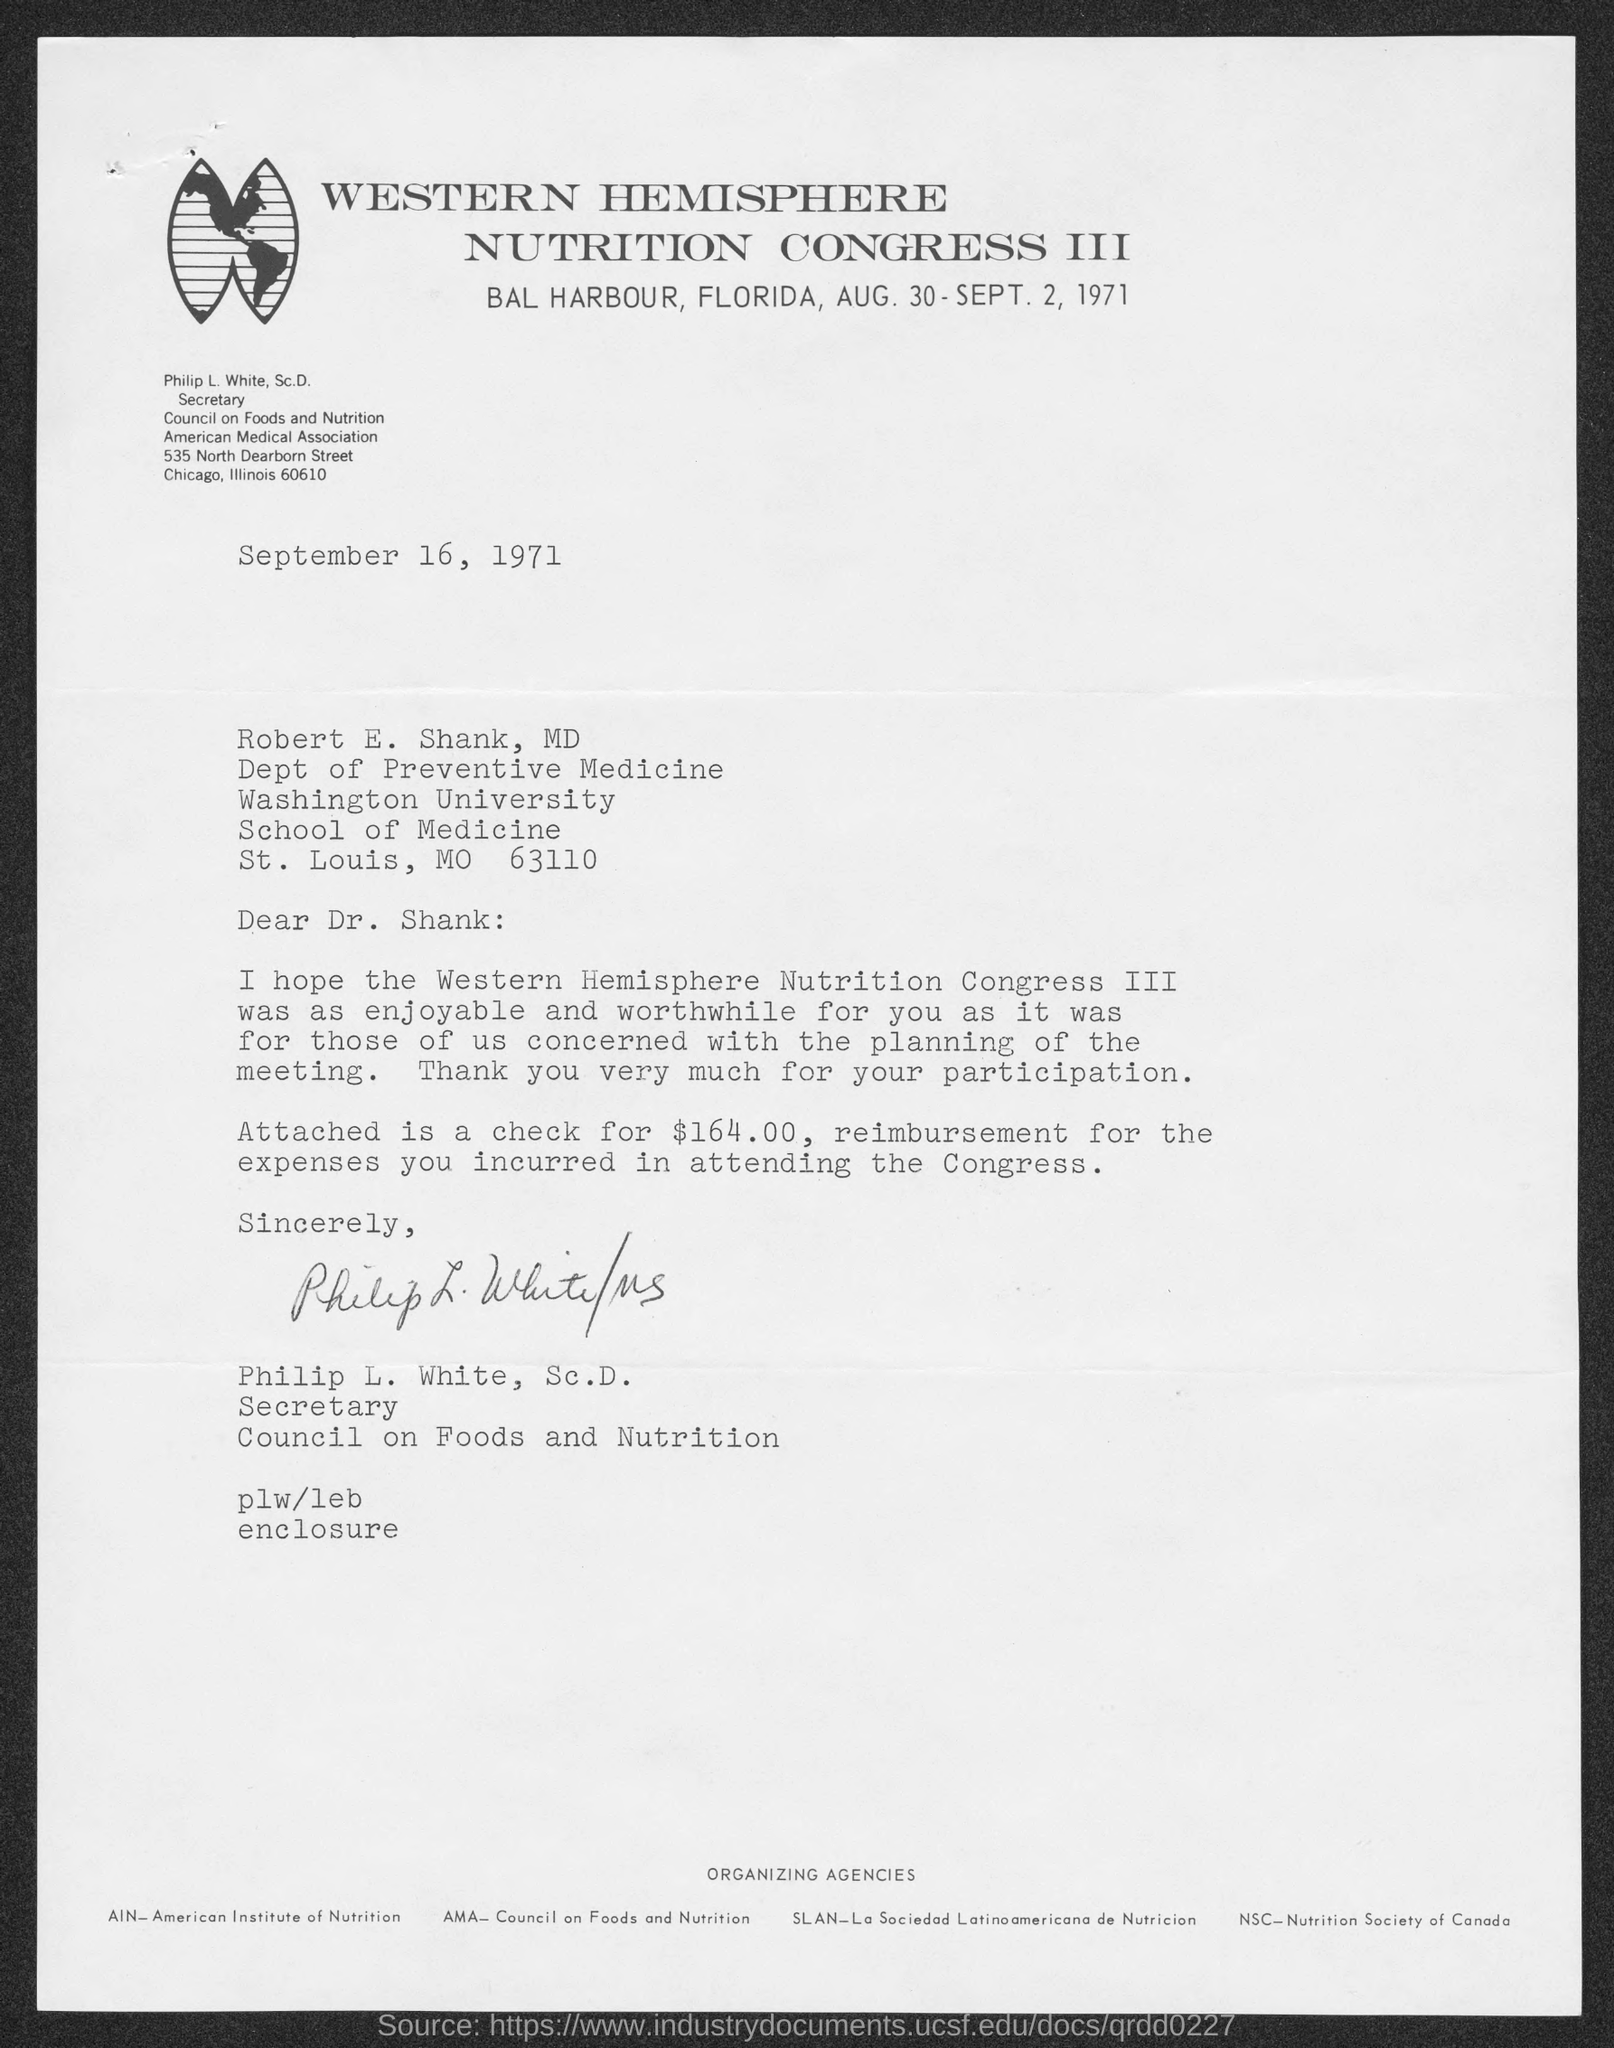What is the title of the congress?
Your answer should be very brief. Western Hemisphere Nutrition Congress III. Where is the congress going to be held?
Your answer should be very brief. BAL HARBOUR, FLORIDA. When is the document dated?
Give a very brief answer. September 16, 1971. How much is the amount of check for reimbursement?
Provide a succinct answer. $164.00. What does AIN stand for?
Ensure brevity in your answer.  American Institute of Nutrition. 